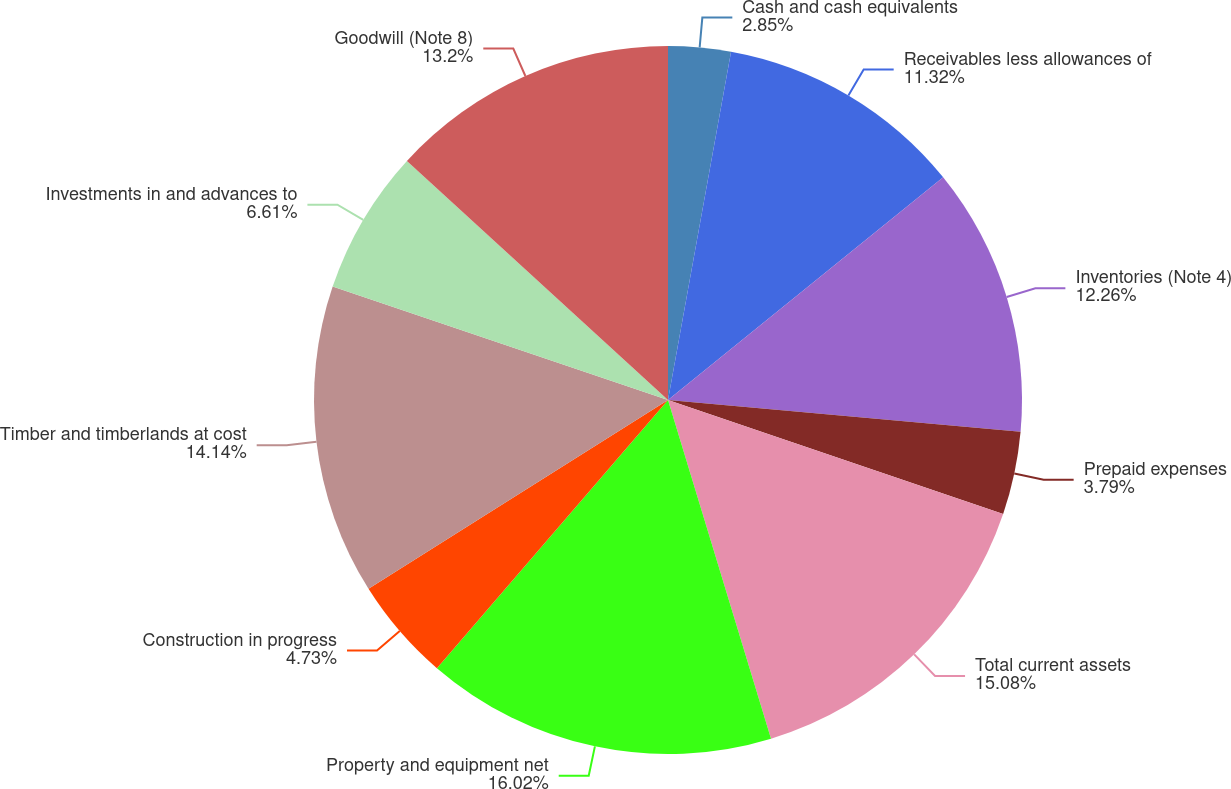Convert chart to OTSL. <chart><loc_0><loc_0><loc_500><loc_500><pie_chart><fcel>Cash and cash equivalents<fcel>Receivables less allowances of<fcel>Inventories (Note 4)<fcel>Prepaid expenses<fcel>Total current assets<fcel>Property and equipment net<fcel>Construction in progress<fcel>Timber and timberlands at cost<fcel>Investments in and advances to<fcel>Goodwill (Note 8)<nl><fcel>2.85%<fcel>11.32%<fcel>12.26%<fcel>3.79%<fcel>15.08%<fcel>16.02%<fcel>4.73%<fcel>14.14%<fcel>6.61%<fcel>13.2%<nl></chart> 